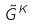Convert formula to latex. <formula><loc_0><loc_0><loc_500><loc_500>\tilde { G } ^ { K }</formula> 